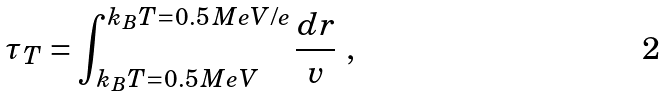<formula> <loc_0><loc_0><loc_500><loc_500>\tau _ { T } = \int _ { \, k _ { B } T = 0 . 5 \, M e V } ^ { k _ { B } T = 0 . 5 \, M e V / e } \frac { d r } { v } \ ,</formula> 